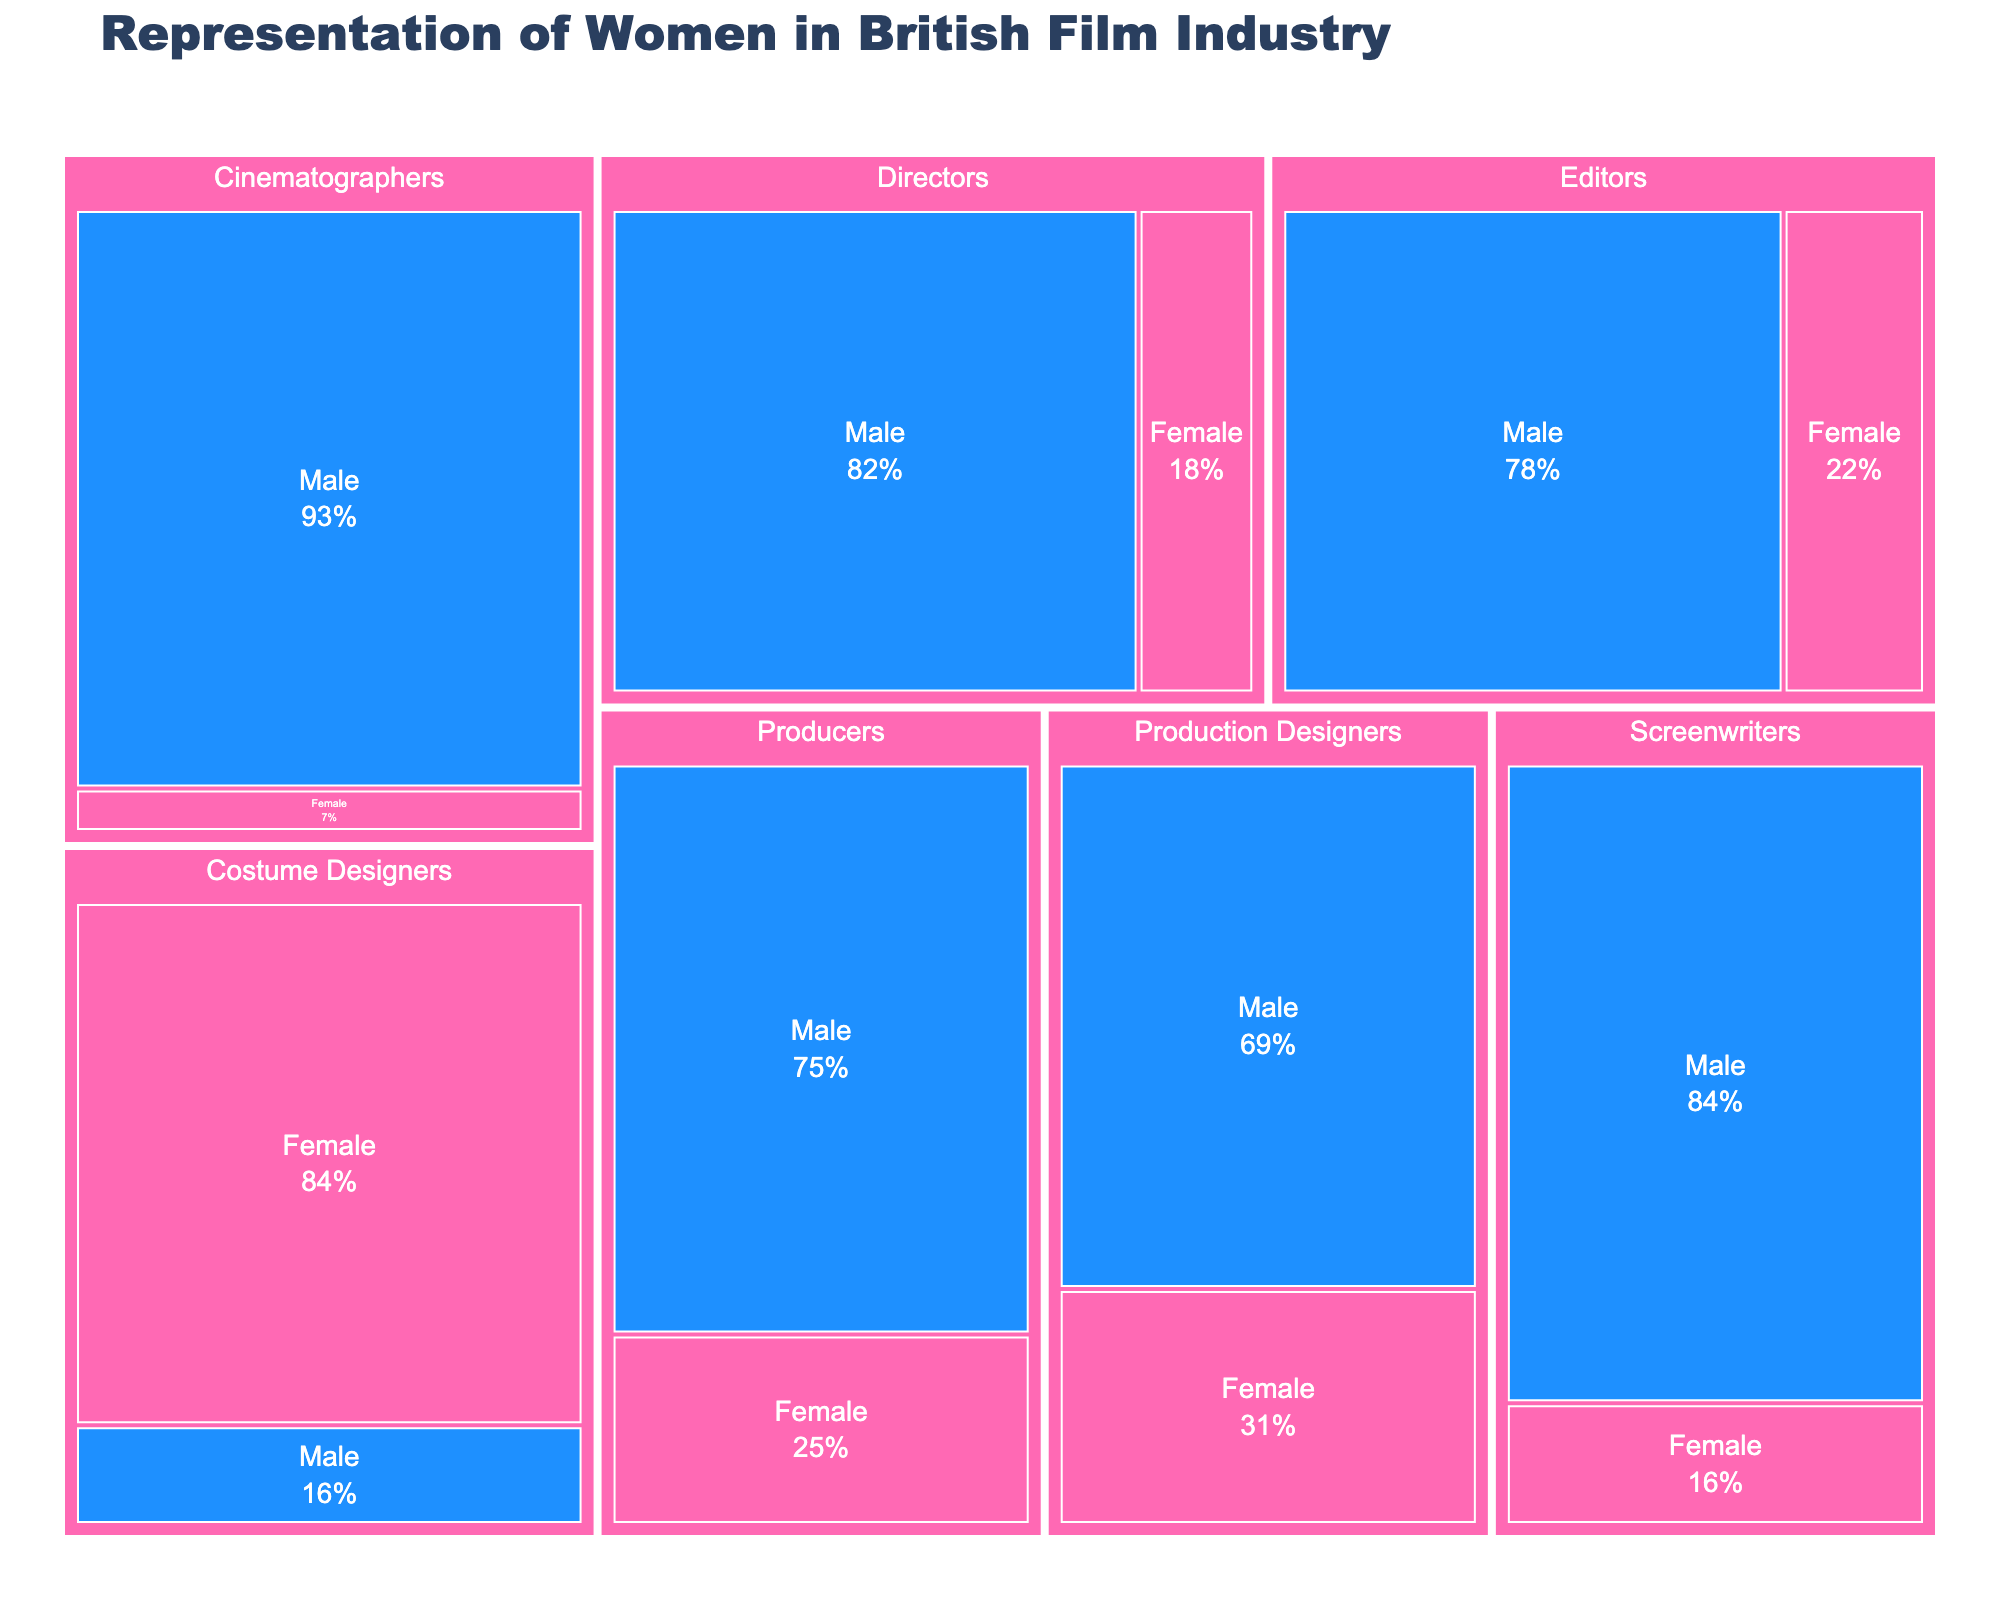What's the title of the treemap? The title of the treemap is displayed prominently at the top of the figure in bold to represent what the treemap is about.
Answer: Representation of Women in British Film Industry Which category has the largest proportion of female representation? By observing the treemap, the biggest colored segment representing females will indicate the largest proportion. The bright pink segment shows the largest percentage in one of the segments.
Answer: Costume Designers What is the percentage of female directors? Locate the 'Directors' section and look at the segment marked 'Female' to find the percentage displayed there.
Answer: 18% Which gender dominates the role of cinematographers? Locate the Cinematographers section and compare the size of the segments for Male and Female. The larger segment indicates dominance.
Answer: Male How many percentage points more are male screenwriters compared to female screenwriters? Find the percentages for both male and female screenwriters and subtract the smaller one from the larger one.
Answer: 68% What's the proportion of female editors versus male editors? Find the segments under Editors for both Female and Male and list their percentages.
Answer: 22% vs. 78% Can you summarize the gender distribution in the role of Producers? Identify the segments for Producers and state the percentages for both genders.
Answer: 25% female, 75% male What is the difference in female representation between Costume Designers and Production Designers? Locate the percentages for both categories and subtract the smaller from the larger one.
Answer: 84% - 31% = 53% Which role has the least representation of females? Compare the percentages of all female segments across various roles. The segment with the smallest percentage is the answer.
Answer: Cinematographers How does the representation of female editors compare to female screenwriters? Observe the female percentages in both the Editors and Screenwriters sections to compare.
Answer: Editors: 22%, Screenwriters: 16% 